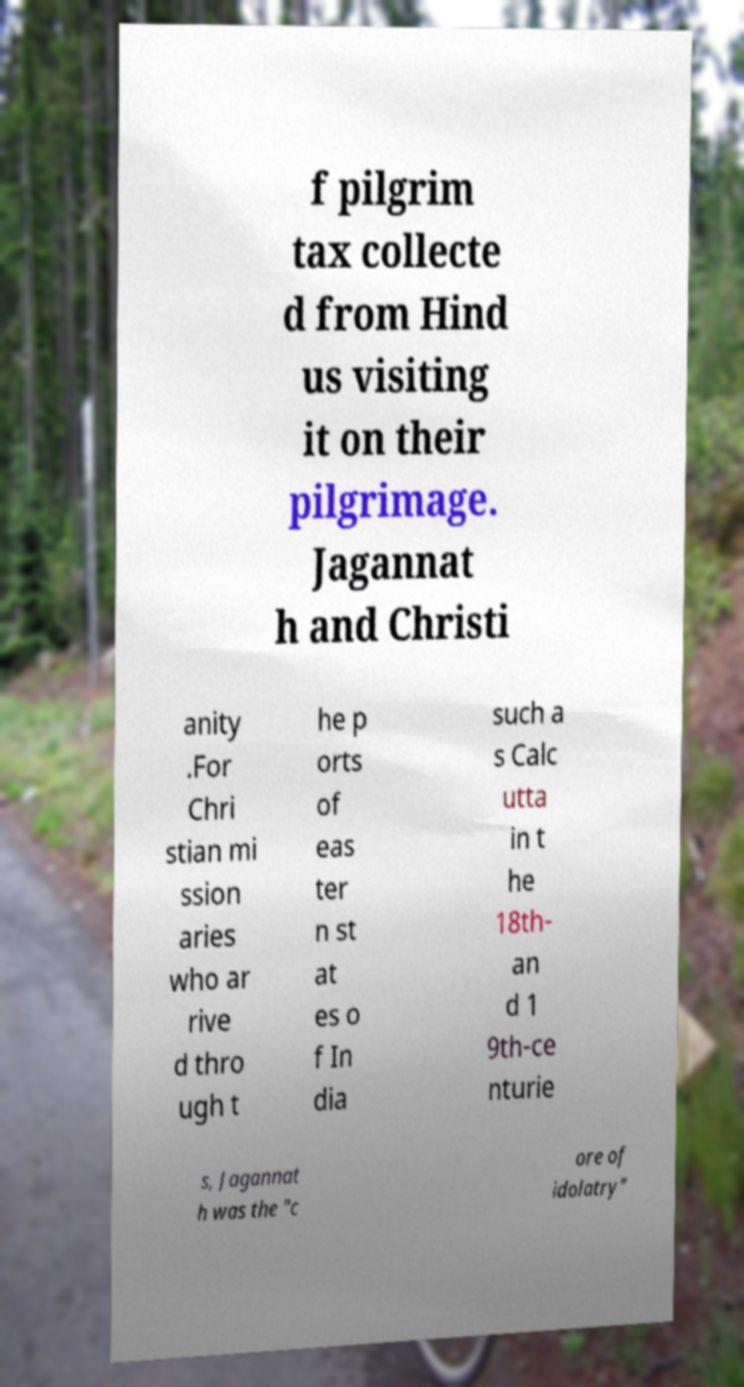Please read and relay the text visible in this image. What does it say? f pilgrim tax collecte d from Hind us visiting it on their pilgrimage. Jagannat h and Christi anity .For Chri stian mi ssion aries who ar rive d thro ugh t he p orts of eas ter n st at es o f In dia such a s Calc utta in t he 18th- an d 1 9th-ce nturie s, Jagannat h was the "c ore of idolatry" 